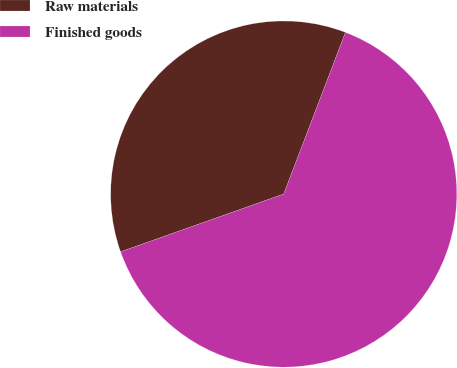<chart> <loc_0><loc_0><loc_500><loc_500><pie_chart><fcel>Raw materials<fcel>Finished goods<nl><fcel>36.22%<fcel>63.78%<nl></chart> 